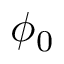<formula> <loc_0><loc_0><loc_500><loc_500>\phi _ { 0 }</formula> 